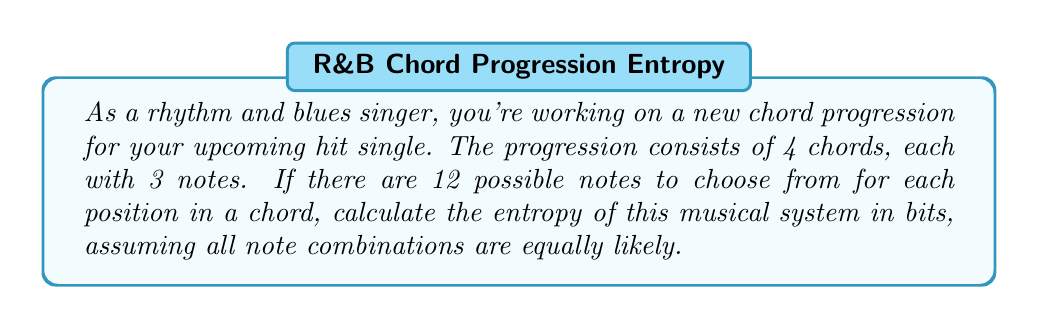Solve this math problem. Let's approach this step-by-step:

1) First, we need to calculate the total number of possible states in our system. For each chord:
   - We have 12 choices for each of the 3 notes
   - The order matters (as it affects the sound of the chord)
   - We can repeat notes

   So, for each chord, we have $12^3 = 1728$ possibilities.

2) For the entire progression of 4 chords, we multiply this by itself 4 times:
   $$(12^3)^4 = 12^{12} = 8,916,100,448,256$$

3) The entropy of a system with $\Omega$ equally likely microstates is given by the Boltzmann formula:

   $$S = k_B \ln(\Omega)$$

   Where $k_B$ is Boltzmann's constant. However, for information entropy measured in bits, we use base-2 logarithm and set $k_B = 1$:

   $$S = \log_2(\Omega)$$

4) Substituting our value for $\Omega$:

   $$S = \log_2(8,916,100,448,256)$$

5) Using a calculator or computer:

   $$S = 43.0000000000000$$

Therefore, the entropy of this musical system is 43 bits.
Answer: 43 bits 